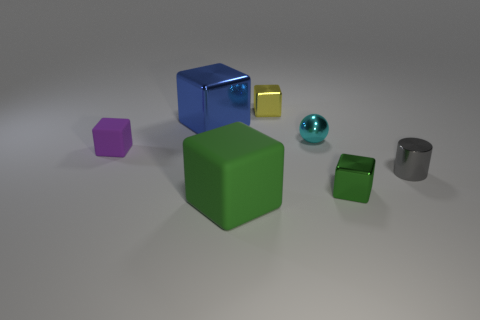There is a object that is both in front of the cyan metallic thing and behind the small gray metallic cylinder; what is its color?
Your answer should be compact. Purple. Does the matte thing on the left side of the blue thing have the same size as the sphere?
Offer a terse response. Yes. What number of objects are either large green things that are to the right of the small purple object or big red cubes?
Offer a very short reply. 1. Is there a object of the same size as the blue metal cube?
Offer a very short reply. Yes. There is a purple cube that is the same size as the shiny sphere; what is its material?
Make the answer very short. Rubber. What is the shape of the thing that is both left of the small yellow object and on the right side of the large blue metal cube?
Make the answer very short. Cube. What color is the shiny cube that is in front of the purple matte cube?
Your response must be concise. Green. There is a object that is in front of the tiny cyan shiny thing and behind the tiny cylinder; what is its size?
Your response must be concise. Small. Is the small green thing made of the same material as the large block in front of the cyan thing?
Offer a very short reply. No. What number of tiny cyan rubber things are the same shape as the large blue object?
Make the answer very short. 0. 